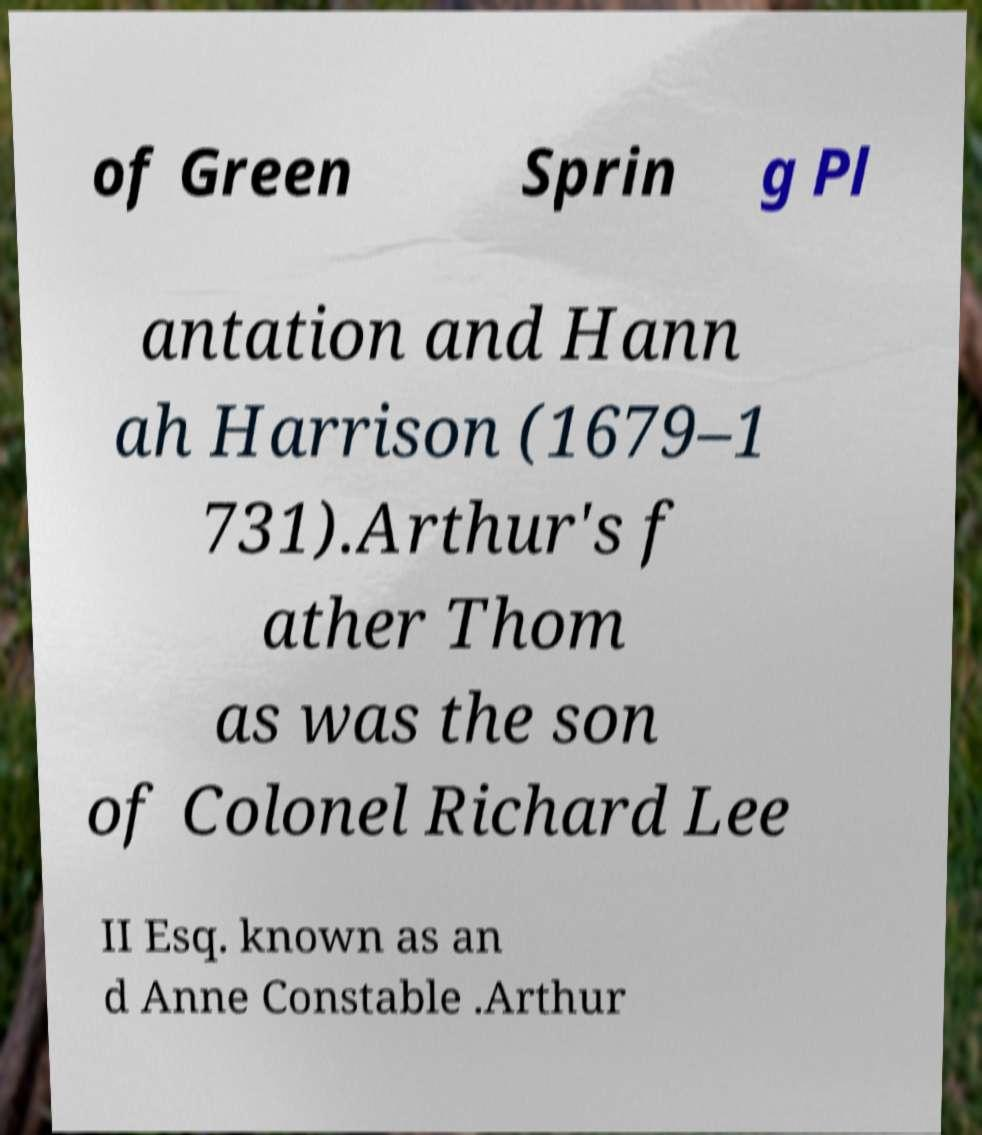Can you accurately transcribe the text from the provided image for me? of Green Sprin g Pl antation and Hann ah Harrison (1679–1 731).Arthur's f ather Thom as was the son of Colonel Richard Lee II Esq. known as an d Anne Constable .Arthur 